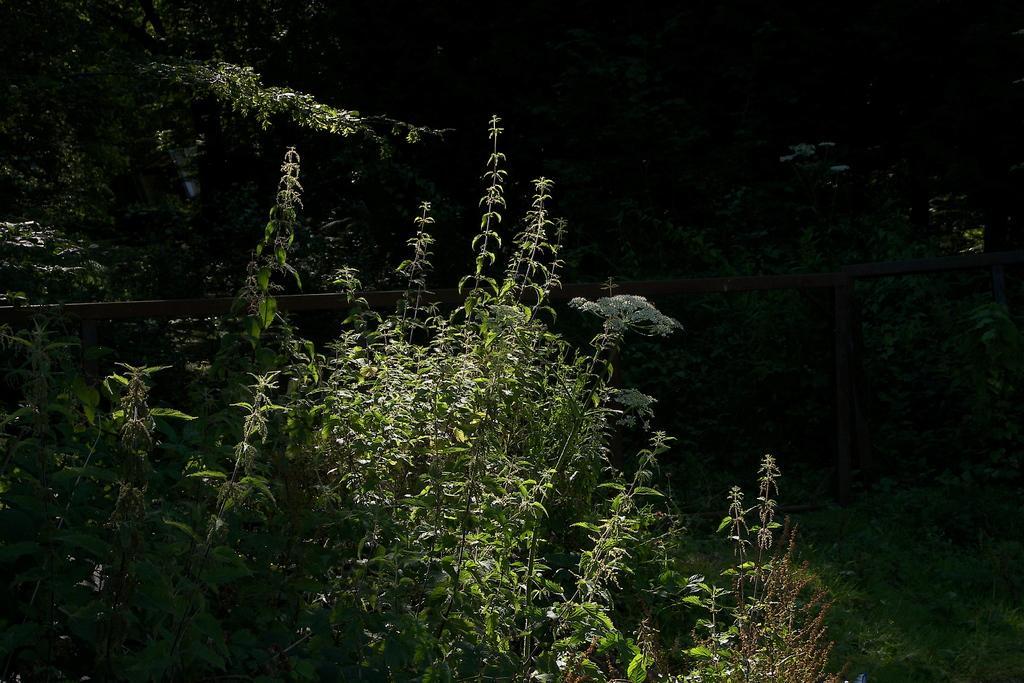How would you summarize this image in a sentence or two? In this picture we can see trees and railing. 